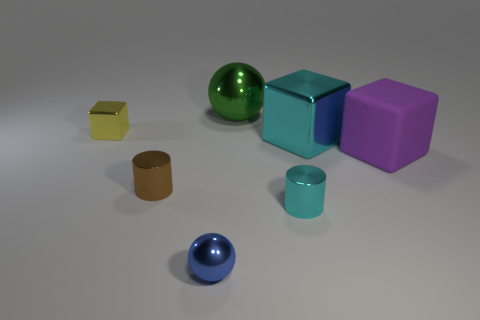Is the material of the big block on the left side of the purple matte thing the same as the yellow cube?
Keep it short and to the point. Yes. What size is the cyan object in front of the big purple matte block?
Offer a very short reply. Small. Are there any small yellow objects behind the big metallic object behind the yellow cube?
Your response must be concise. No. Does the shiny sphere that is in front of the large rubber thing have the same color as the big metallic object that is to the right of the green metal sphere?
Give a very brief answer. No. What is the color of the rubber block?
Your response must be concise. Purple. Are there any other things that have the same color as the large metallic cube?
Your response must be concise. Yes. The big thing that is both in front of the tiny shiny block and to the left of the big purple matte thing is what color?
Make the answer very short. Cyan. There is a cylinder to the right of the green metal ball; does it have the same size as the purple block?
Provide a short and direct response. No. Are there more brown things that are on the left side of the yellow shiny object than metallic cylinders?
Make the answer very short. No. Is the purple object the same shape as the tiny yellow thing?
Provide a succinct answer. Yes. 